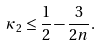<formula> <loc_0><loc_0><loc_500><loc_500>\kappa _ { 2 } \leq \frac { 1 } { 2 } - \frac { 3 } { 2 n } .</formula> 